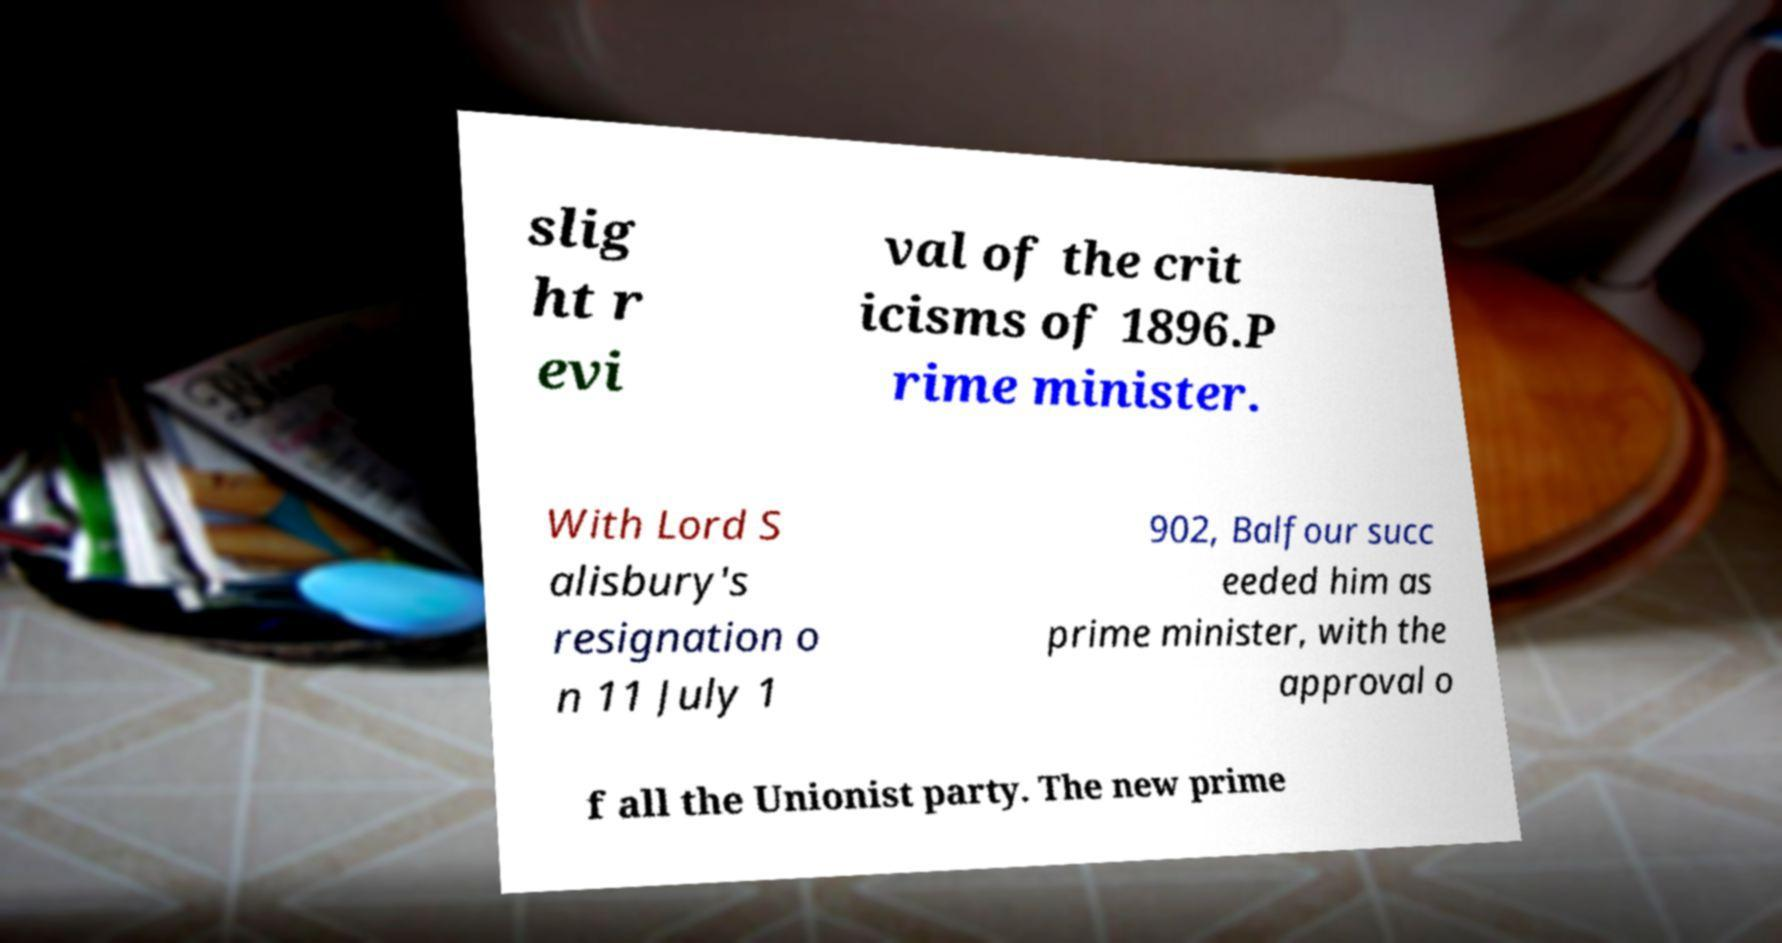What messages or text are displayed in this image? I need them in a readable, typed format. slig ht r evi val of the crit icisms of 1896.P rime minister. With Lord S alisbury's resignation o n 11 July 1 902, Balfour succ eeded him as prime minister, with the approval o f all the Unionist party. The new prime 